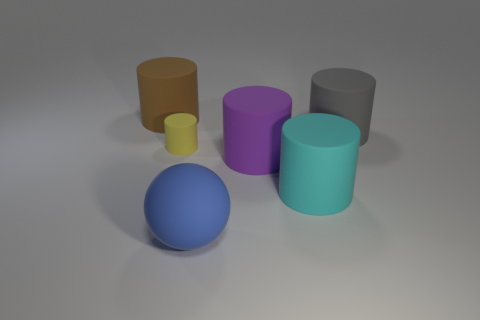Can you describe the colors of the objects in the image from left to right? Starting from the left, there is a brown cylinder, a blue sphere, a purple cylinder, a grey cylinder, and a teal cylinder. A small yellow cylinder is positioned in front of the purple one. 